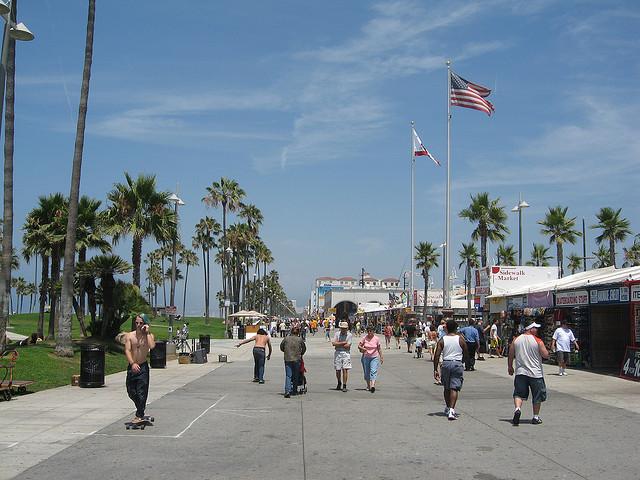Are these people about to go on vacation?
Write a very short answer. No. How many kids are skating?
Write a very short answer. 2. Does this day look bright and sunny?
Answer briefly. Yes. Are the palm trees high?
Give a very brief answer. Yes. Where are the flags?
Give a very brief answer. Poles. How many skateboards are visible?
Concise answer only. 1. Where are the people walking?
Write a very short answer. Sidewalk. How many flags are there?
Be succinct. 2. Is it a clear or cloudy day?
Answer briefly. Clear. Can one go on a skateboard with just one leg?
Answer briefly. Yes. Can you spot cars?
Write a very short answer. No. 